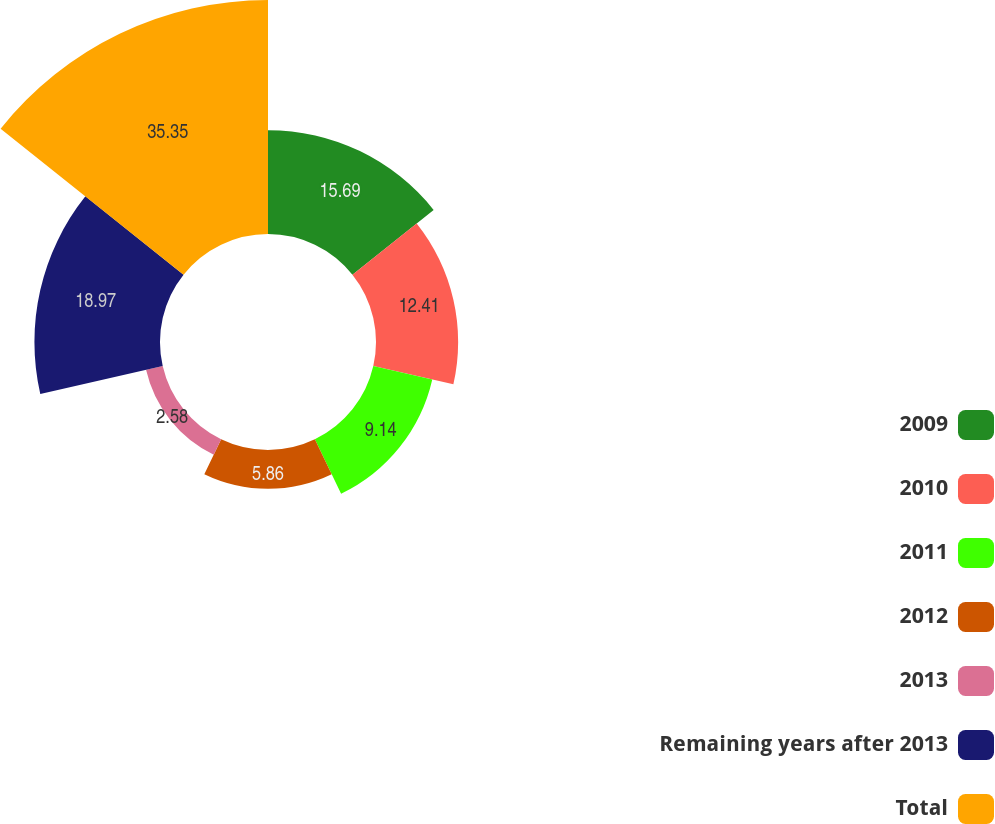Convert chart to OTSL. <chart><loc_0><loc_0><loc_500><loc_500><pie_chart><fcel>2009<fcel>2010<fcel>2011<fcel>2012<fcel>2013<fcel>Remaining years after 2013<fcel>Total<nl><fcel>15.69%<fcel>12.41%<fcel>9.14%<fcel>5.86%<fcel>2.58%<fcel>18.97%<fcel>35.35%<nl></chart> 